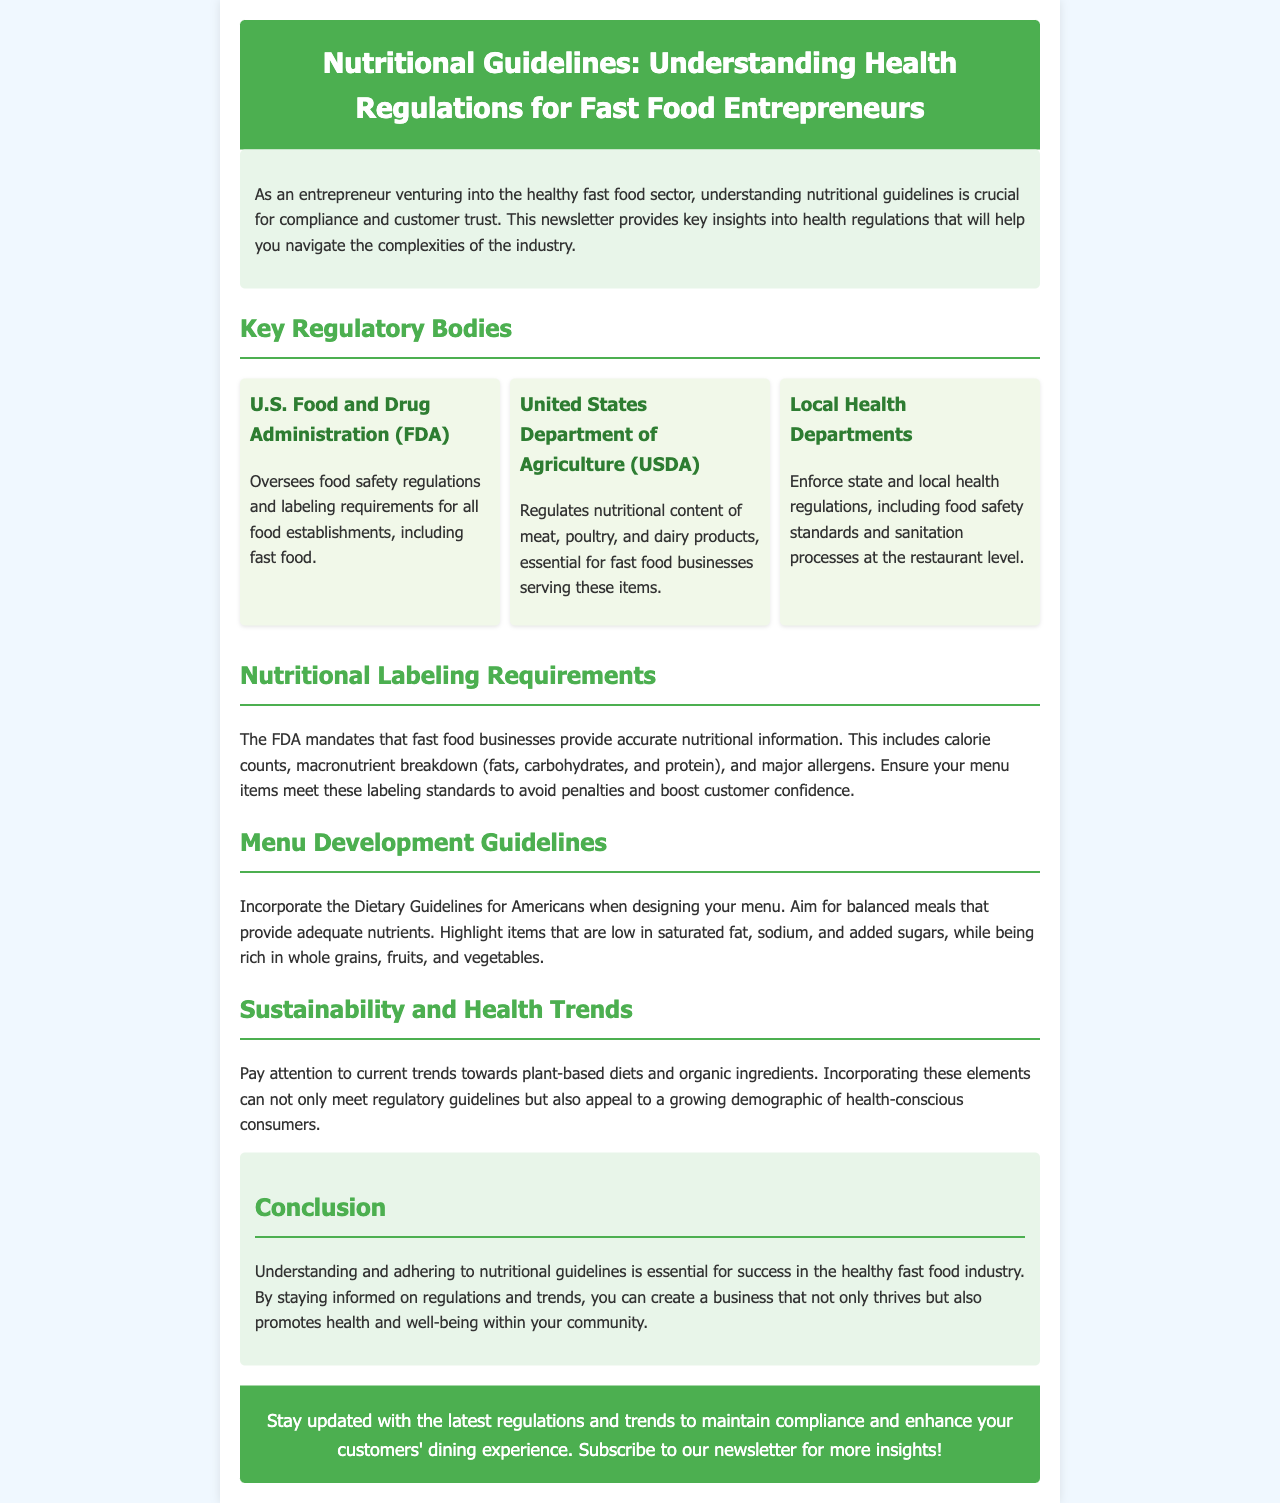What is the primary focus of this newsletter? The newsletter mainly focuses on understanding nutritional guidelines and health regulations for fast food entrepreneurs.
Answer: nutritional guidelines Which organization oversees food safety regulations? The U.S. Food and Drug Administration oversees food safety regulations and labeling requirements for all food establishments.
Answer: FDA What must fast food businesses provide according to the FDA? Fast food businesses must provide accurate nutritional information, including calorie counts, macronutrient breakdown, and allergens.
Answer: nutritional information What type of diets should fast food entrepreneurs pay attention to? Entrepreneurs should pay attention to the trend towards plant-based diets and organic ingredients.
Answer: plant-based diets What should fast food menus highlight according to the Dietary Guidelines for Americans? Menus should highlight items that are low in saturated fat, sodium, and added sugars, while being rich in whole grains, fruits, and vegetables.
Answer: low in saturated fat Which department regulates nutritional content of meat, poultry, and dairy products? The United States Department of Agriculture regulates the nutritional content of these products.
Answer: USDA 